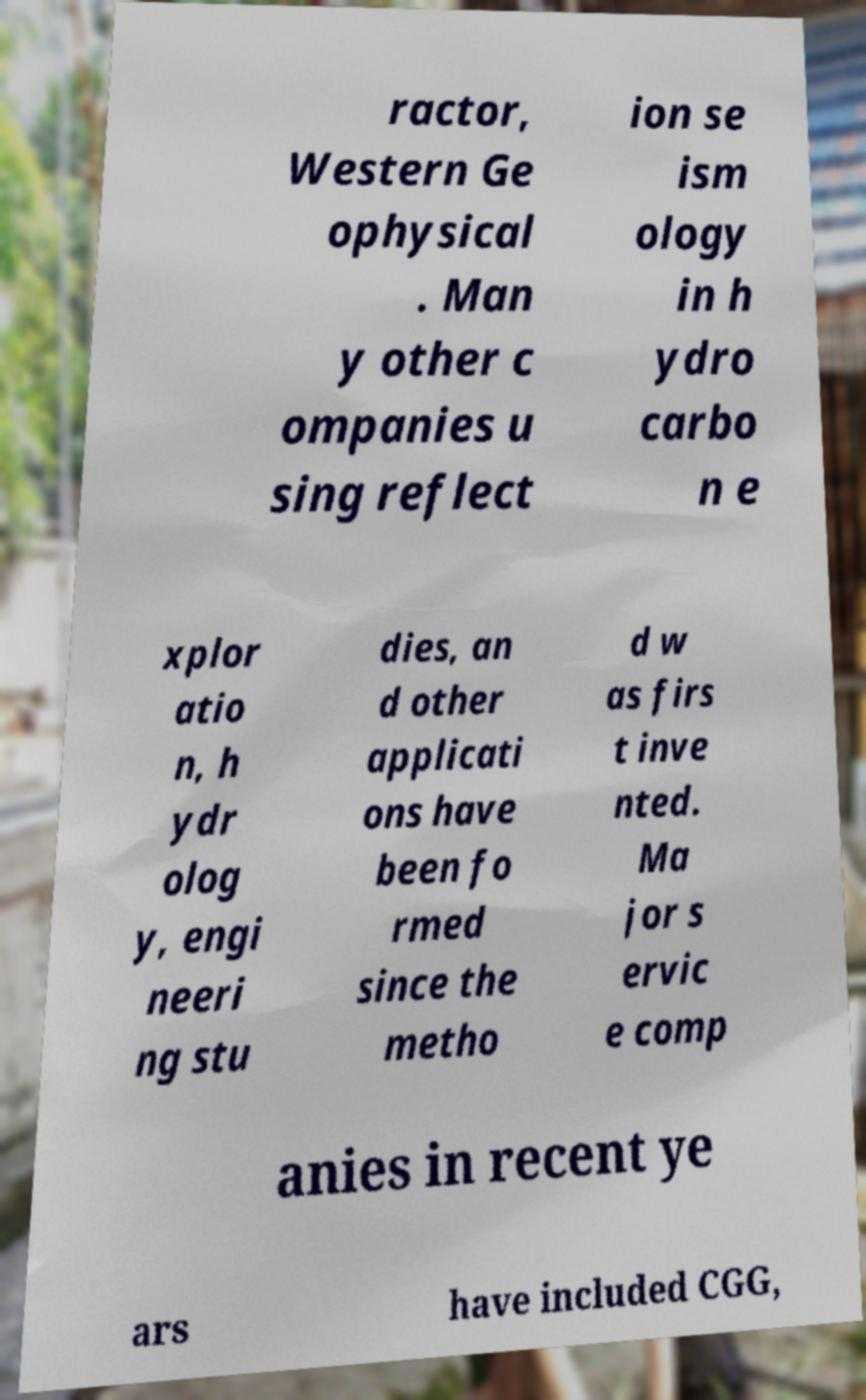For documentation purposes, I need the text within this image transcribed. Could you provide that? ractor, Western Ge ophysical . Man y other c ompanies u sing reflect ion se ism ology in h ydro carbo n e xplor atio n, h ydr olog y, engi neeri ng stu dies, an d other applicati ons have been fo rmed since the metho d w as firs t inve nted. Ma jor s ervic e comp anies in recent ye ars have included CGG, 